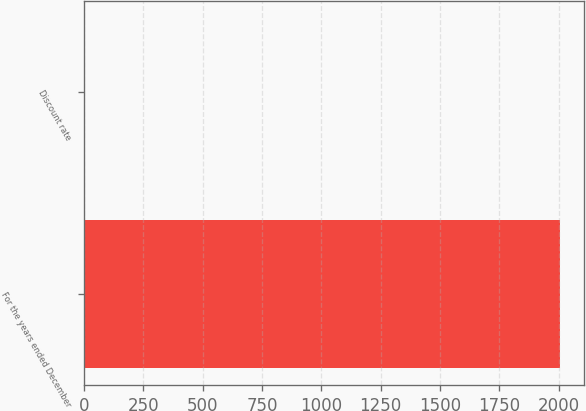<chart> <loc_0><loc_0><loc_500><loc_500><bar_chart><fcel>For the years ended December<fcel>Discount rate<nl><fcel>2004<fcel>6<nl></chart> 